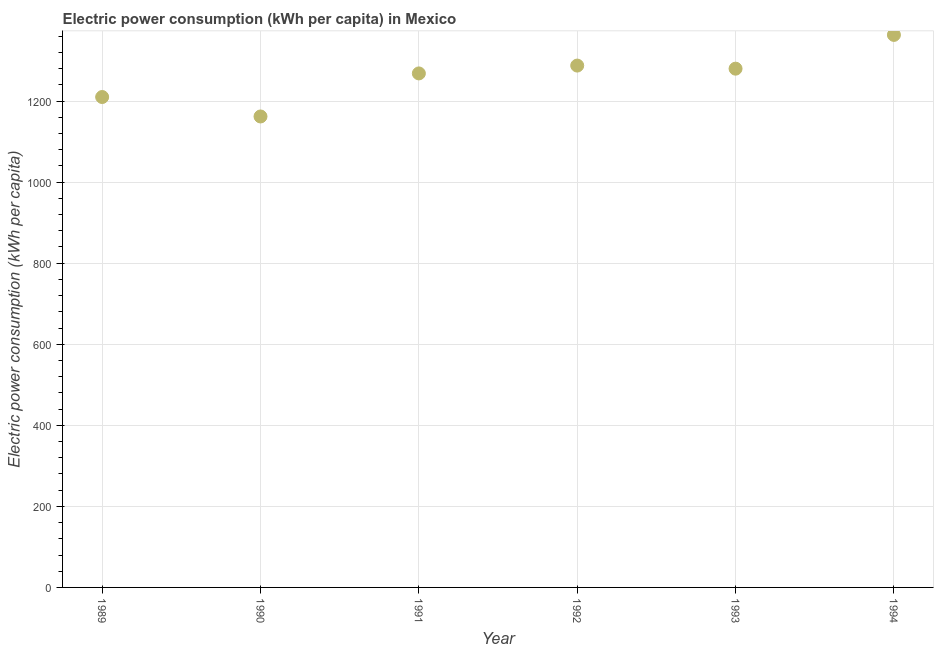What is the electric power consumption in 1991?
Provide a succinct answer. 1268.2. Across all years, what is the maximum electric power consumption?
Your answer should be very brief. 1363.22. Across all years, what is the minimum electric power consumption?
Ensure brevity in your answer.  1161.98. In which year was the electric power consumption maximum?
Your answer should be very brief. 1994. What is the sum of the electric power consumption?
Keep it short and to the point. 7570.81. What is the difference between the electric power consumption in 1990 and 1992?
Your answer should be compact. -125.57. What is the average electric power consumption per year?
Ensure brevity in your answer.  1261.8. What is the median electric power consumption?
Your answer should be compact. 1274.05. In how many years, is the electric power consumption greater than 1160 kWh per capita?
Keep it short and to the point. 6. What is the ratio of the electric power consumption in 1992 to that in 1993?
Give a very brief answer. 1.01. Is the electric power consumption in 1989 less than that in 1990?
Keep it short and to the point. No. Is the difference between the electric power consumption in 1990 and 1992 greater than the difference between any two years?
Provide a short and direct response. No. What is the difference between the highest and the second highest electric power consumption?
Offer a very short reply. 75.68. Is the sum of the electric power consumption in 1990 and 1991 greater than the maximum electric power consumption across all years?
Offer a very short reply. Yes. What is the difference between the highest and the lowest electric power consumption?
Offer a very short reply. 201.25. In how many years, is the electric power consumption greater than the average electric power consumption taken over all years?
Offer a very short reply. 4. Does the graph contain grids?
Provide a short and direct response. Yes. What is the title of the graph?
Offer a terse response. Electric power consumption (kWh per capita) in Mexico. What is the label or title of the Y-axis?
Make the answer very short. Electric power consumption (kWh per capita). What is the Electric power consumption (kWh per capita) in 1989?
Offer a terse response. 1209.96. What is the Electric power consumption (kWh per capita) in 1990?
Your answer should be compact. 1161.98. What is the Electric power consumption (kWh per capita) in 1991?
Provide a short and direct response. 1268.2. What is the Electric power consumption (kWh per capita) in 1992?
Offer a terse response. 1287.54. What is the Electric power consumption (kWh per capita) in 1993?
Your answer should be compact. 1279.91. What is the Electric power consumption (kWh per capita) in 1994?
Your response must be concise. 1363.22. What is the difference between the Electric power consumption (kWh per capita) in 1989 and 1990?
Your answer should be very brief. 47.99. What is the difference between the Electric power consumption (kWh per capita) in 1989 and 1991?
Your response must be concise. -58.24. What is the difference between the Electric power consumption (kWh per capita) in 1989 and 1992?
Your response must be concise. -77.58. What is the difference between the Electric power consumption (kWh per capita) in 1989 and 1993?
Offer a terse response. -69.94. What is the difference between the Electric power consumption (kWh per capita) in 1989 and 1994?
Provide a succinct answer. -153.26. What is the difference between the Electric power consumption (kWh per capita) in 1990 and 1991?
Ensure brevity in your answer.  -106.23. What is the difference between the Electric power consumption (kWh per capita) in 1990 and 1992?
Your response must be concise. -125.57. What is the difference between the Electric power consumption (kWh per capita) in 1990 and 1993?
Provide a short and direct response. -117.93. What is the difference between the Electric power consumption (kWh per capita) in 1990 and 1994?
Provide a short and direct response. -201.25. What is the difference between the Electric power consumption (kWh per capita) in 1991 and 1992?
Your answer should be very brief. -19.34. What is the difference between the Electric power consumption (kWh per capita) in 1991 and 1993?
Provide a short and direct response. -11.7. What is the difference between the Electric power consumption (kWh per capita) in 1991 and 1994?
Offer a terse response. -95.02. What is the difference between the Electric power consumption (kWh per capita) in 1992 and 1993?
Make the answer very short. 7.64. What is the difference between the Electric power consumption (kWh per capita) in 1992 and 1994?
Offer a very short reply. -75.68. What is the difference between the Electric power consumption (kWh per capita) in 1993 and 1994?
Offer a very short reply. -83.31. What is the ratio of the Electric power consumption (kWh per capita) in 1989 to that in 1990?
Provide a short and direct response. 1.04. What is the ratio of the Electric power consumption (kWh per capita) in 1989 to that in 1991?
Ensure brevity in your answer.  0.95. What is the ratio of the Electric power consumption (kWh per capita) in 1989 to that in 1992?
Offer a very short reply. 0.94. What is the ratio of the Electric power consumption (kWh per capita) in 1989 to that in 1993?
Your answer should be compact. 0.94. What is the ratio of the Electric power consumption (kWh per capita) in 1989 to that in 1994?
Offer a very short reply. 0.89. What is the ratio of the Electric power consumption (kWh per capita) in 1990 to that in 1991?
Ensure brevity in your answer.  0.92. What is the ratio of the Electric power consumption (kWh per capita) in 1990 to that in 1992?
Your answer should be compact. 0.9. What is the ratio of the Electric power consumption (kWh per capita) in 1990 to that in 1993?
Your answer should be very brief. 0.91. What is the ratio of the Electric power consumption (kWh per capita) in 1990 to that in 1994?
Offer a very short reply. 0.85. What is the ratio of the Electric power consumption (kWh per capita) in 1991 to that in 1993?
Provide a short and direct response. 0.99. What is the ratio of the Electric power consumption (kWh per capita) in 1991 to that in 1994?
Give a very brief answer. 0.93. What is the ratio of the Electric power consumption (kWh per capita) in 1992 to that in 1994?
Give a very brief answer. 0.94. What is the ratio of the Electric power consumption (kWh per capita) in 1993 to that in 1994?
Give a very brief answer. 0.94. 